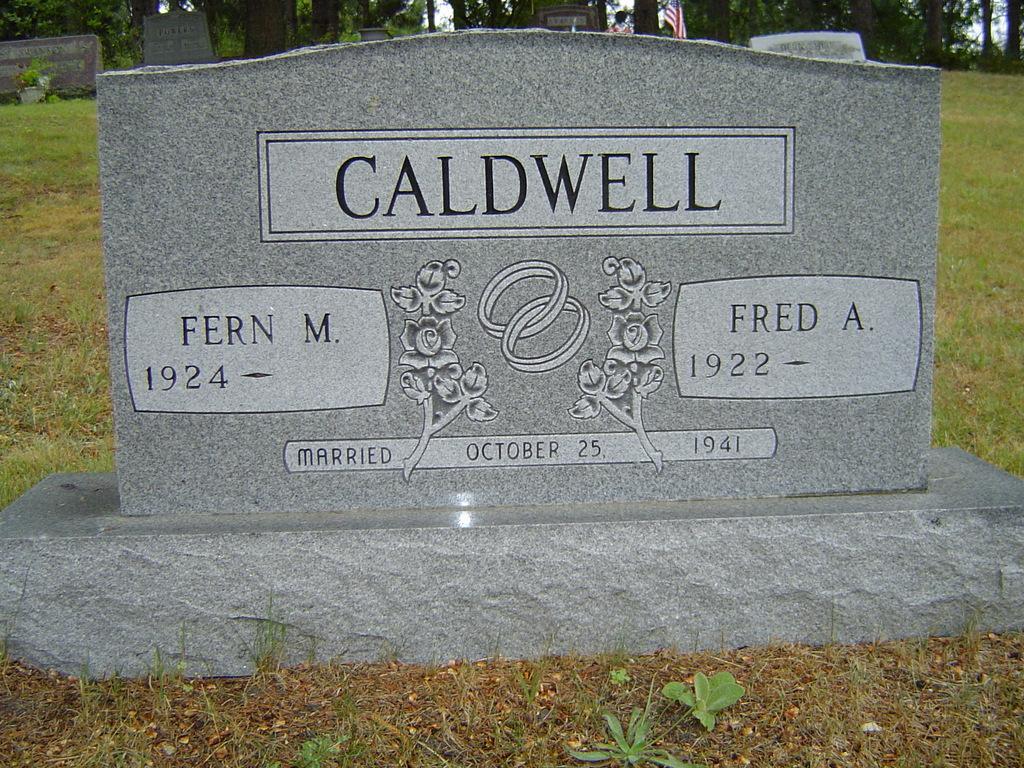Could you give a brief overview of what you see in this image? In this picture we can see many graves. In the center we can see the flower design and dates on the granite stone. At the bottom we can see the grass. In the background we can see many trees, flag and the sky. 